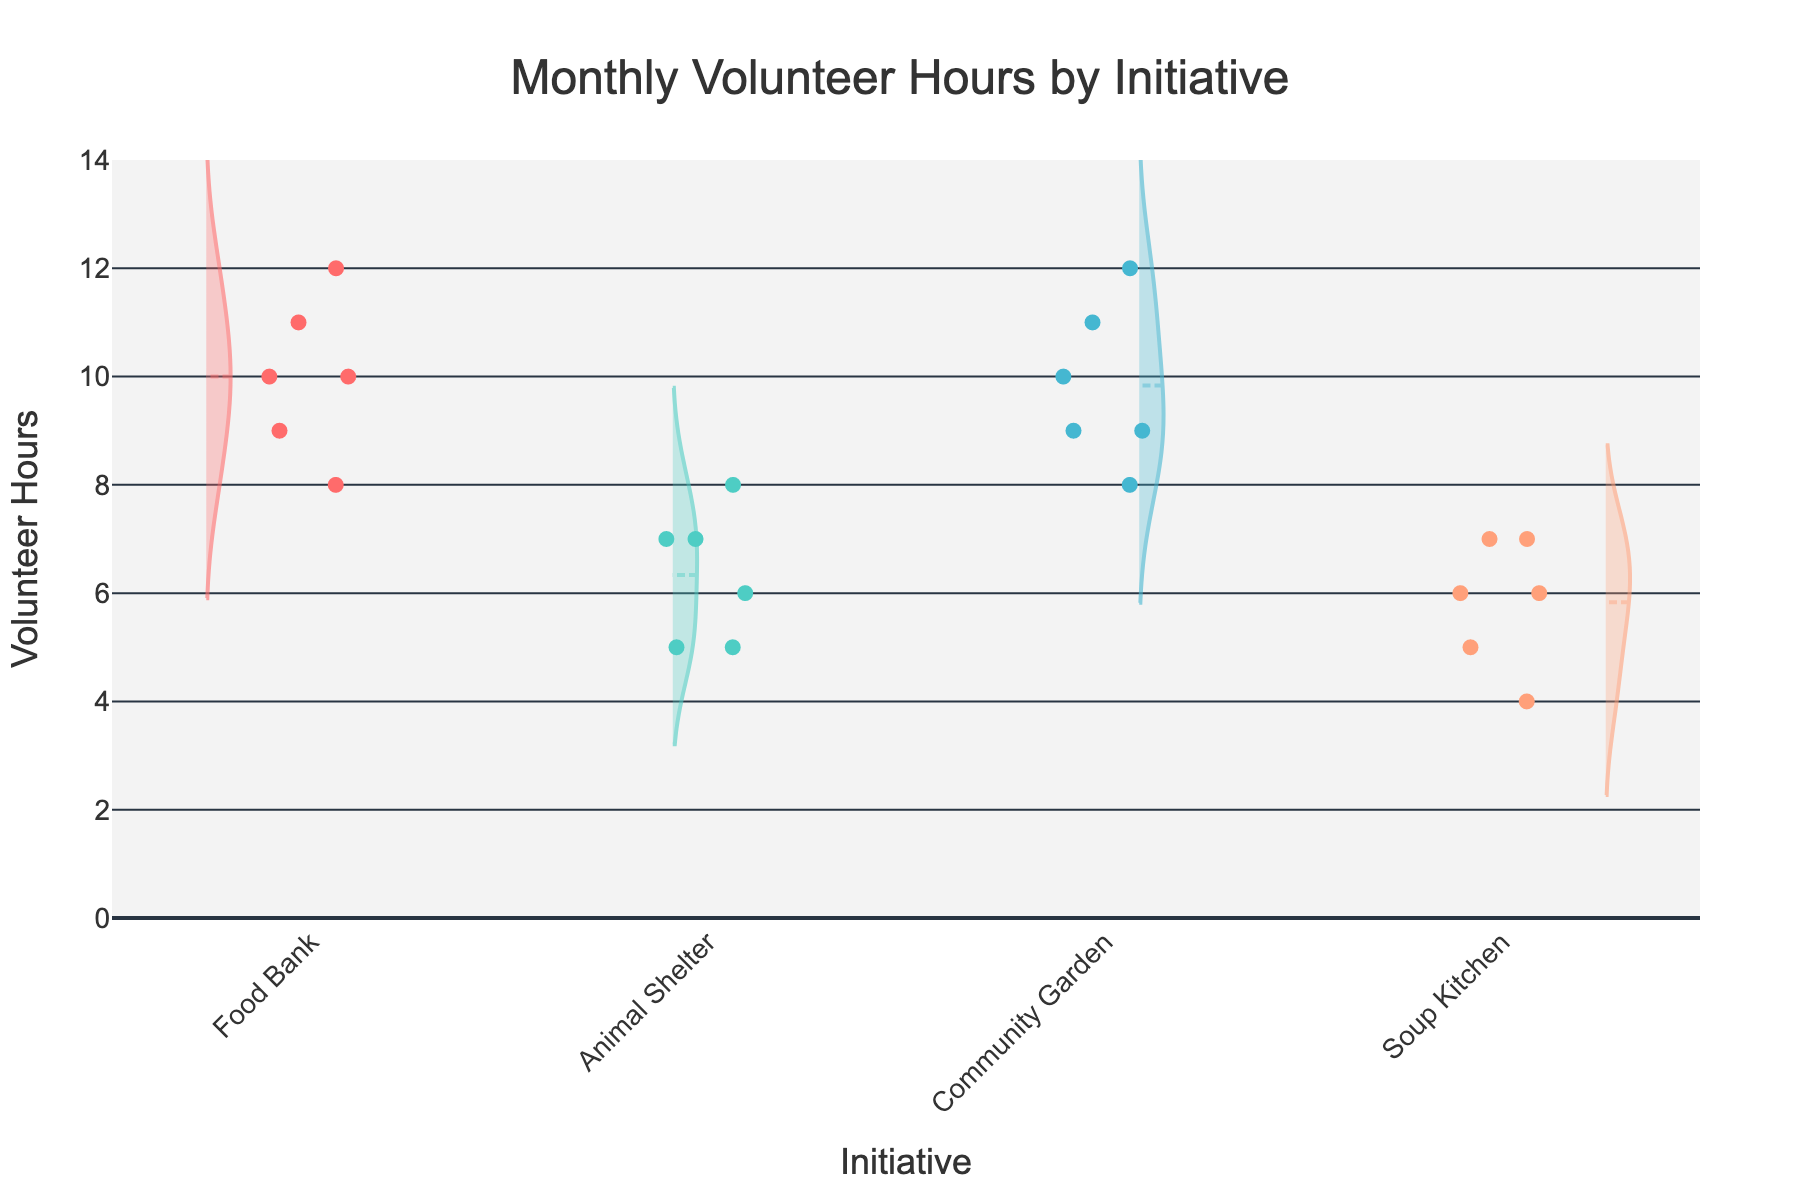Which initiative had the highest individual volunteer hours recorded? Look at the violin plot and identify the highest data point. The Community Garden in January shows the highest individual hours with 12.
Answer: Community Garden What's the average volunteer hours for the Food Bank initiative across all months? Find the data points for the Food Bank and calculate their average. The hours are 10, 8, 9, 11, 12, and 10. Sum these (10+8+9+11+12+10) to get 60, then divide by 6.
Answer: 10 Which initiative had the most variability in volunteer hours? Examine the width of the violin plots. The wider the plot, the more variability it has. The Food Bank initiative shows the most variability with a wider spread of data points.
Answer: Food Bank How many hours did volunteers contribute to the Animal Shelter in March? Identify the tick marks for Animal Shelter in March and count the data points within that category. The recorded hours are 6 and 8. Sum these values.
Answer: 14 Is there a trend in volunteer hours for the Community Garden over the months? Observe the changes in the central tendency lines and data spread in the Community Garden's violin plots across months. The volunteer hours start at high with a slight downward trend (12, 9, 10, 8, 11, 9).
Answer: Slight downward trend Compare the median volunteer hours between the Soup Kitchen and Community Garden initiatives. Which one is higher? Identify the central line in the violin plot (median line). The Community Garden's central line is higher compared to the Soup Kitchen's.
Answer: Community Garden How many volunteers contributed to the Food Bank initiative in February? Look for the individual data points in February under the Food Bank category and count them. There are 2 volunteers as evidenced by two points.
Answer: 2 Which month shows the highest total volunteer hours across all initiatives? Sum all the hours recorded in each month and compare. January: 10+8+5+7+12+9+6+4 = 61, February: 9+11+7+5+10+8+7+6 = 63, March: 12+10+6+8+11+9+5+7 = 68. March has the highest total hours.
Answer: March What is the mean volunteer hours for January across all initiatives? Sum the recorded hours for January and divide by the number of entries. (10+8+5+7+12+9+6+4) = 61, and there are 8 entries.
Answer: 7.625 Which month had the highest median volunteer hours for the Food Bank initiative? Compare the central lines of the violin plots for the Food Bank across different months. March has the highest median with a line closer to 11.
Answer: March 